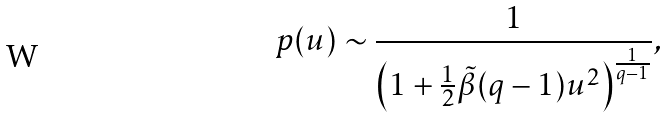<formula> <loc_0><loc_0><loc_500><loc_500>p ( u ) \sim \frac { 1 } { \left ( 1 + \frac { 1 } { 2 } \tilde { \beta } ( q - 1 ) u ^ { 2 } \right ) ^ { \frac { 1 } { q - 1 } } } ,</formula> 